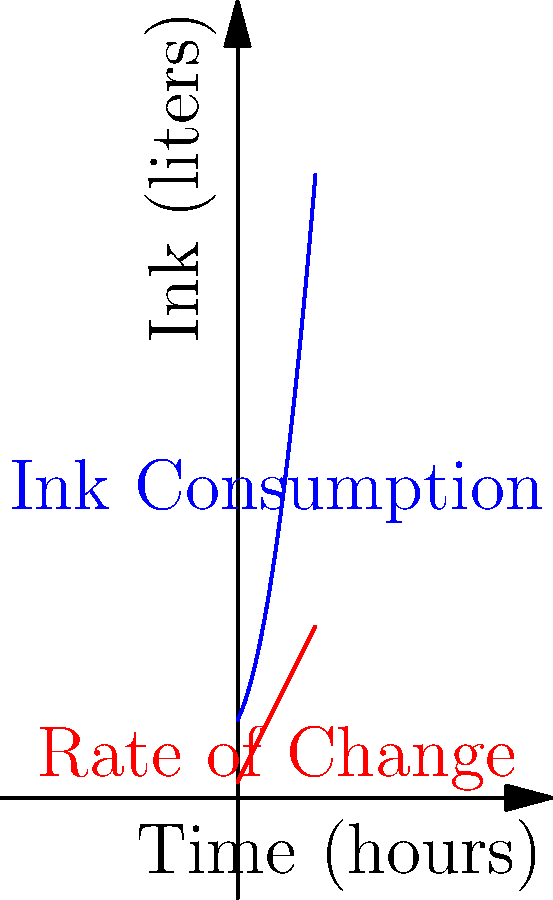A large banner printing job is underway, and the ink consumption (in liters) over time (in hours) is modeled by the function $f(t) = 0.5t^2 + 2t + 10$, where $t$ is the time in hours since the start of the job. At what point during the first 10 hours of printing is the rate of ink consumption exactly 12 liters per hour? To solve this problem, we need to follow these steps:

1) The rate of ink consumption is given by the derivative of the ink consumption function. Let's call this rate function $f'(t)$.

2) We can find $f'(t)$ by differentiating $f(t)$:
   $f'(t) = \frac{d}{dt}(0.5t^2 + 2t + 10) = t + 2$

3) We're looking for the time when the rate of consumption is 12 liters per hour. This means we need to solve the equation:
   $f'(t) = 12$

4) Substituting our expression for $f'(t)$:
   $t + 2 = 12$

5) Solving for $t$:
   $t = 12 - 2 = 10$

6) We need to check if this solution falls within the first 10 hours of printing. Since $t = 10$, it occurs exactly at the 10-hour mark, which satisfies our condition.

Therefore, the rate of ink consumption is exactly 12 liters per hour at the 10-hour mark of the printing job.
Answer: 10 hours 